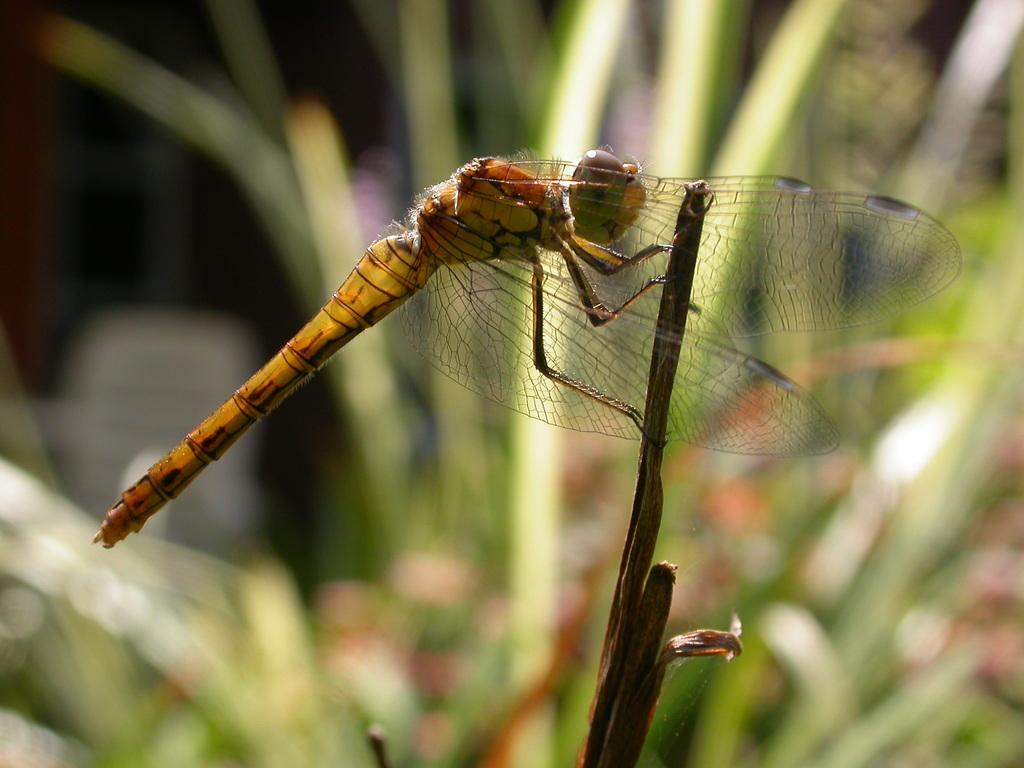What is the main subject of the image? There is a dragonfly in the image. Where is the dragonfly located? The dragonfly is on an object. Can you describe the background of the image? The background of the image is blurred. How many chickens are present in the image? There are no chickens present in the image; it features a dragonfly on an object with a blurred background. What type of mass is being celebrated in the image? There is no indication of a mass or celebration in the image; it features a dragonfly on an object with a blurred background. 